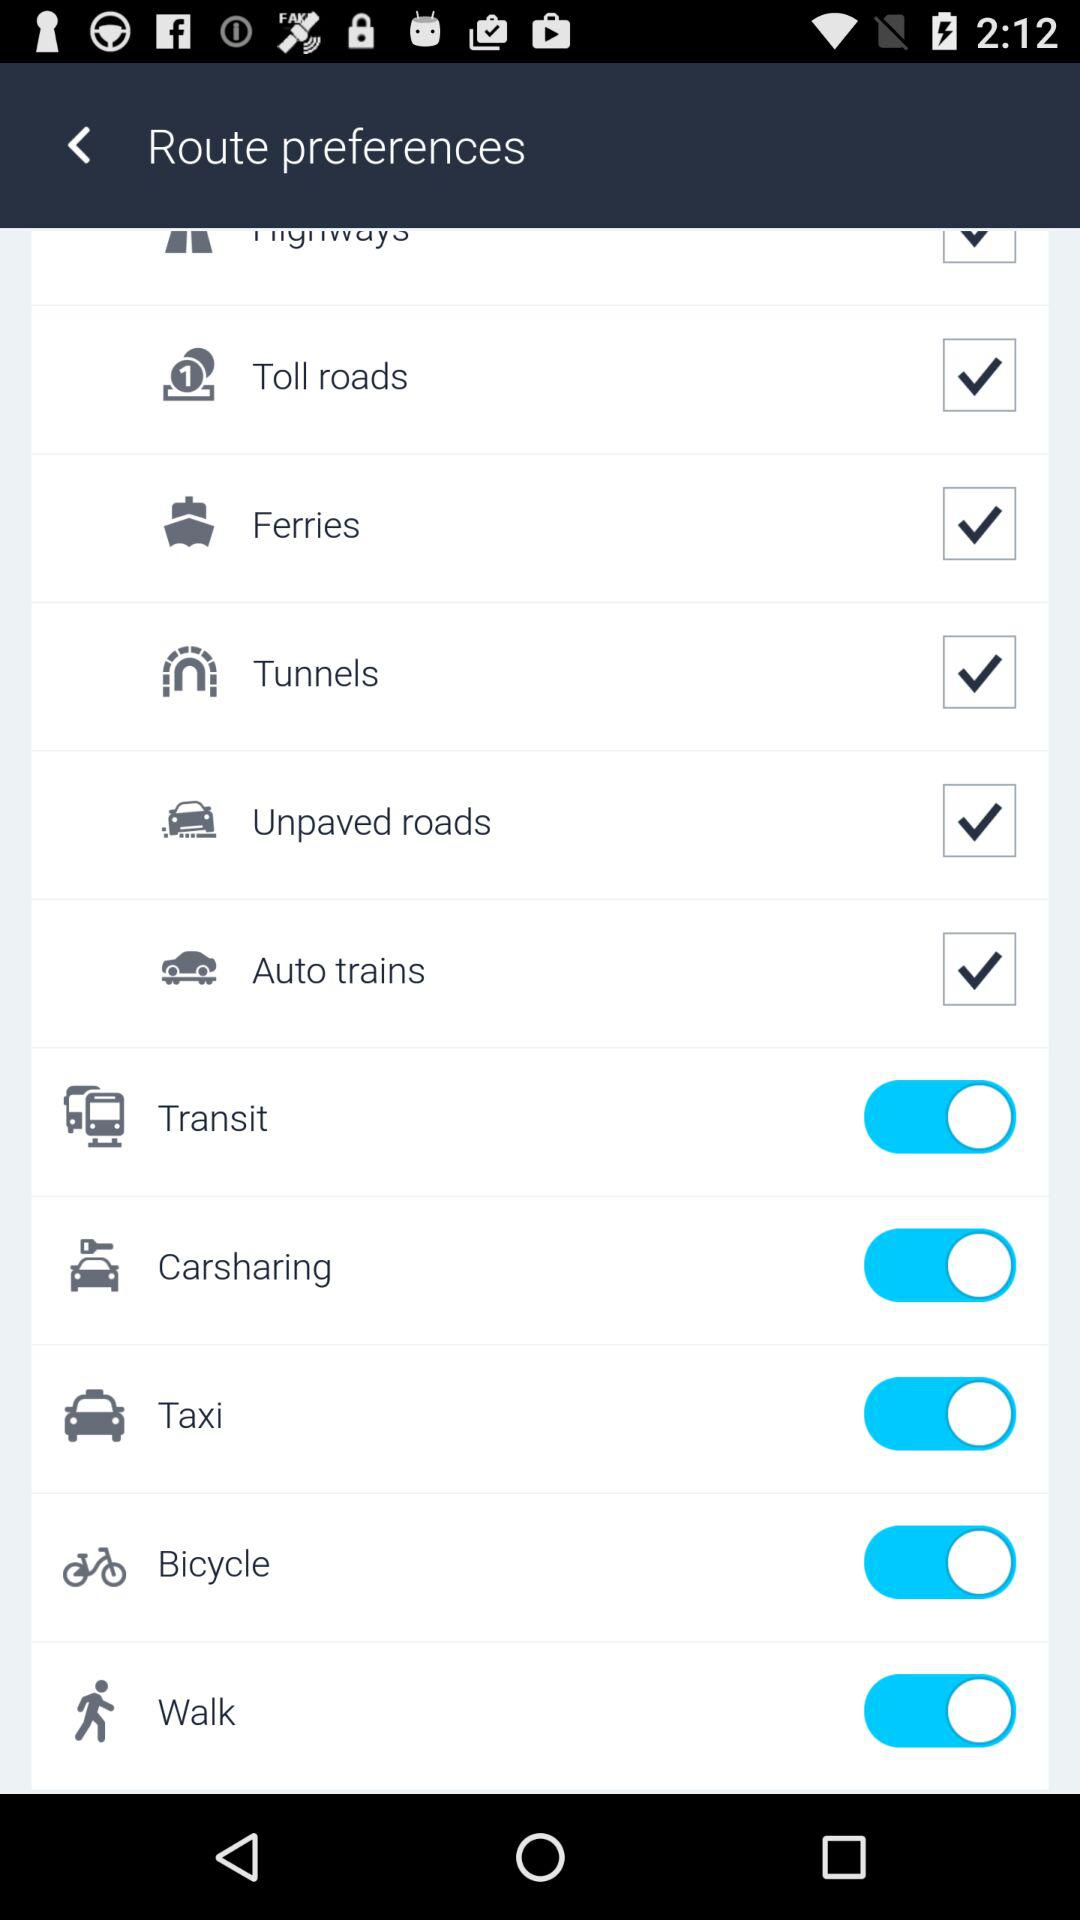What are the selected options? The selected options are: "Toll roads", "Ferries", "Tunnels", "Unpaved roads" and "Auto trains". 